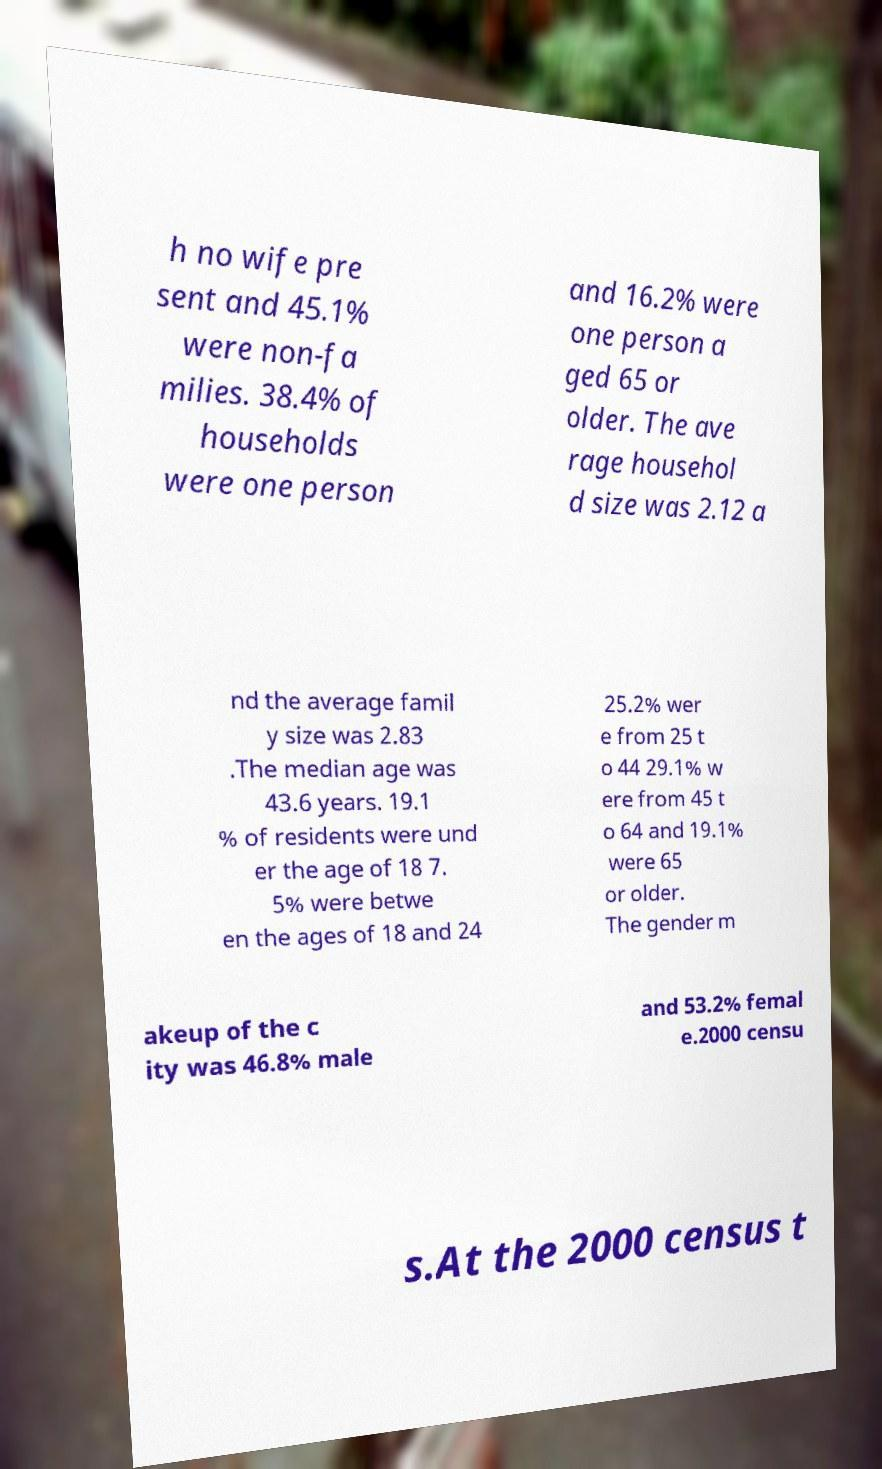Can you read and provide the text displayed in the image?This photo seems to have some interesting text. Can you extract and type it out for me? h no wife pre sent and 45.1% were non-fa milies. 38.4% of households were one person and 16.2% were one person a ged 65 or older. The ave rage househol d size was 2.12 a nd the average famil y size was 2.83 .The median age was 43.6 years. 19.1 % of residents were und er the age of 18 7. 5% were betwe en the ages of 18 and 24 25.2% wer e from 25 t o 44 29.1% w ere from 45 t o 64 and 19.1% were 65 or older. The gender m akeup of the c ity was 46.8% male and 53.2% femal e.2000 censu s.At the 2000 census t 